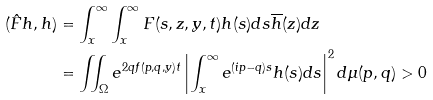<formula> <loc_0><loc_0><loc_500><loc_500>( \hat { F } h , h ) & = \int _ { x } ^ { \infty } \int _ { x } ^ { \infty } F ( s , z , y , t ) h ( s ) d s \overline { h } ( z ) d z \\ & = \iint _ { \Omega } e ^ { 2 q f ( p , q , y ) t } \left | \int _ { x } ^ { \infty } e ^ { ( i p - q ) s } h ( s ) d s \right | ^ { 2 } d \mu ( p , q ) > 0</formula> 